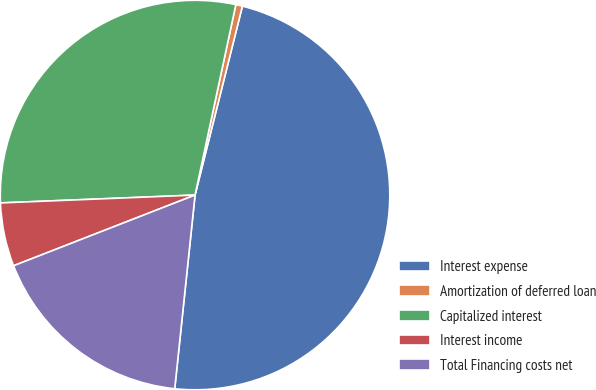Convert chart. <chart><loc_0><loc_0><loc_500><loc_500><pie_chart><fcel>Interest expense<fcel>Amortization of deferred loan<fcel>Capitalized interest<fcel>Interest income<fcel>Total Financing costs net<nl><fcel>47.75%<fcel>0.55%<fcel>29.0%<fcel>5.27%<fcel>17.42%<nl></chart> 